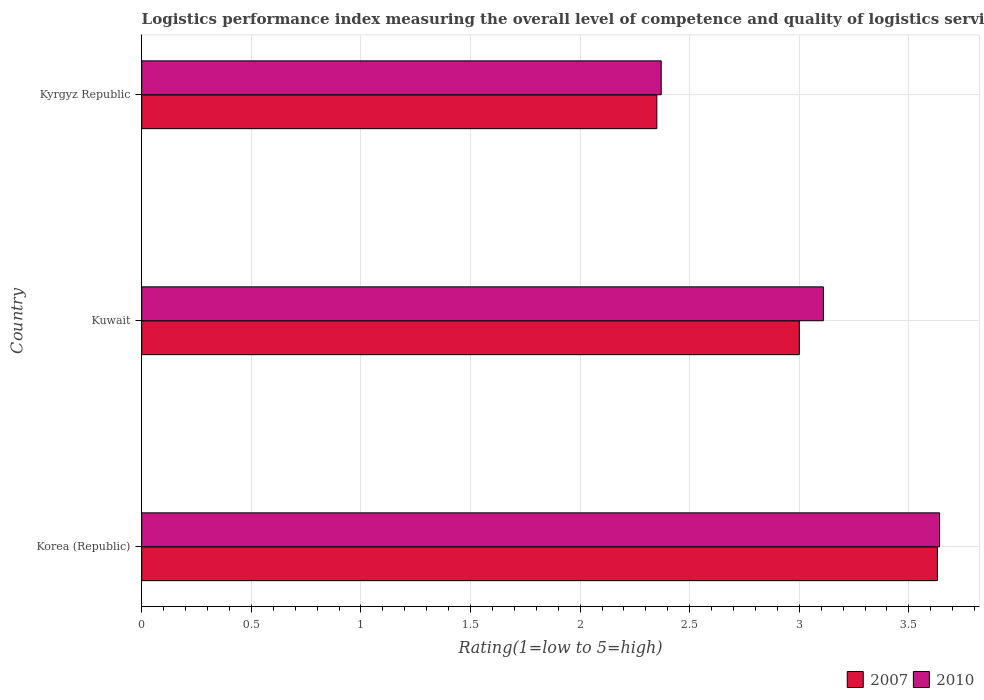How many bars are there on the 2nd tick from the bottom?
Offer a terse response. 2. What is the label of the 2nd group of bars from the top?
Provide a succinct answer. Kuwait. In how many cases, is the number of bars for a given country not equal to the number of legend labels?
Make the answer very short. 0. What is the Logistic performance index in 2010 in Kyrgyz Republic?
Your response must be concise. 2.37. Across all countries, what is the maximum Logistic performance index in 2007?
Keep it short and to the point. 3.63. Across all countries, what is the minimum Logistic performance index in 2007?
Offer a very short reply. 2.35. In which country was the Logistic performance index in 2007 minimum?
Offer a very short reply. Kyrgyz Republic. What is the total Logistic performance index in 2007 in the graph?
Your answer should be compact. 8.98. What is the difference between the Logistic performance index in 2007 in Korea (Republic) and that in Kyrgyz Republic?
Provide a succinct answer. 1.28. What is the difference between the Logistic performance index in 2007 in Kuwait and the Logistic performance index in 2010 in Korea (Republic)?
Ensure brevity in your answer.  -0.64. What is the average Logistic performance index in 2010 per country?
Provide a short and direct response. 3.04. What is the difference between the Logistic performance index in 2007 and Logistic performance index in 2010 in Korea (Republic)?
Make the answer very short. -0.01. What is the ratio of the Logistic performance index in 2010 in Korea (Republic) to that in Kyrgyz Republic?
Provide a succinct answer. 1.54. Is the Logistic performance index in 2007 in Kuwait less than that in Kyrgyz Republic?
Provide a succinct answer. No. Is the difference between the Logistic performance index in 2007 in Korea (Republic) and Kyrgyz Republic greater than the difference between the Logistic performance index in 2010 in Korea (Republic) and Kyrgyz Republic?
Ensure brevity in your answer.  Yes. What is the difference between the highest and the second highest Logistic performance index in 2010?
Your response must be concise. 0.53. What is the difference between the highest and the lowest Logistic performance index in 2007?
Your answer should be very brief. 1.28. How many bars are there?
Offer a very short reply. 6. Are the values on the major ticks of X-axis written in scientific E-notation?
Provide a short and direct response. No. Does the graph contain grids?
Provide a short and direct response. Yes. What is the title of the graph?
Your answer should be very brief. Logistics performance index measuring the overall level of competence and quality of logistics services. Does "2005" appear as one of the legend labels in the graph?
Offer a very short reply. No. What is the label or title of the X-axis?
Ensure brevity in your answer.  Rating(1=low to 5=high). What is the label or title of the Y-axis?
Offer a terse response. Country. What is the Rating(1=low to 5=high) in 2007 in Korea (Republic)?
Your answer should be compact. 3.63. What is the Rating(1=low to 5=high) of 2010 in Korea (Republic)?
Offer a terse response. 3.64. What is the Rating(1=low to 5=high) in 2007 in Kuwait?
Provide a short and direct response. 3. What is the Rating(1=low to 5=high) in 2010 in Kuwait?
Offer a very short reply. 3.11. What is the Rating(1=low to 5=high) of 2007 in Kyrgyz Republic?
Your answer should be very brief. 2.35. What is the Rating(1=low to 5=high) in 2010 in Kyrgyz Republic?
Provide a short and direct response. 2.37. Across all countries, what is the maximum Rating(1=low to 5=high) of 2007?
Your answer should be compact. 3.63. Across all countries, what is the maximum Rating(1=low to 5=high) of 2010?
Keep it short and to the point. 3.64. Across all countries, what is the minimum Rating(1=low to 5=high) in 2007?
Your answer should be compact. 2.35. Across all countries, what is the minimum Rating(1=low to 5=high) of 2010?
Give a very brief answer. 2.37. What is the total Rating(1=low to 5=high) in 2007 in the graph?
Make the answer very short. 8.98. What is the total Rating(1=low to 5=high) in 2010 in the graph?
Give a very brief answer. 9.12. What is the difference between the Rating(1=low to 5=high) of 2007 in Korea (Republic) and that in Kuwait?
Your answer should be very brief. 0.63. What is the difference between the Rating(1=low to 5=high) of 2010 in Korea (Republic) and that in Kuwait?
Keep it short and to the point. 0.53. What is the difference between the Rating(1=low to 5=high) in 2007 in Korea (Republic) and that in Kyrgyz Republic?
Keep it short and to the point. 1.28. What is the difference between the Rating(1=low to 5=high) in 2010 in Korea (Republic) and that in Kyrgyz Republic?
Offer a very short reply. 1.27. What is the difference between the Rating(1=low to 5=high) of 2007 in Kuwait and that in Kyrgyz Republic?
Provide a succinct answer. 0.65. What is the difference between the Rating(1=low to 5=high) in 2010 in Kuwait and that in Kyrgyz Republic?
Keep it short and to the point. 0.74. What is the difference between the Rating(1=low to 5=high) in 2007 in Korea (Republic) and the Rating(1=low to 5=high) in 2010 in Kuwait?
Provide a short and direct response. 0.52. What is the difference between the Rating(1=low to 5=high) of 2007 in Korea (Republic) and the Rating(1=low to 5=high) of 2010 in Kyrgyz Republic?
Provide a succinct answer. 1.26. What is the difference between the Rating(1=low to 5=high) of 2007 in Kuwait and the Rating(1=low to 5=high) of 2010 in Kyrgyz Republic?
Provide a succinct answer. 0.63. What is the average Rating(1=low to 5=high) of 2007 per country?
Offer a very short reply. 2.99. What is the average Rating(1=low to 5=high) of 2010 per country?
Your answer should be compact. 3.04. What is the difference between the Rating(1=low to 5=high) in 2007 and Rating(1=low to 5=high) in 2010 in Korea (Republic)?
Keep it short and to the point. -0.01. What is the difference between the Rating(1=low to 5=high) in 2007 and Rating(1=low to 5=high) in 2010 in Kuwait?
Provide a short and direct response. -0.11. What is the difference between the Rating(1=low to 5=high) of 2007 and Rating(1=low to 5=high) of 2010 in Kyrgyz Republic?
Offer a very short reply. -0.02. What is the ratio of the Rating(1=low to 5=high) of 2007 in Korea (Republic) to that in Kuwait?
Give a very brief answer. 1.21. What is the ratio of the Rating(1=low to 5=high) in 2010 in Korea (Republic) to that in Kuwait?
Offer a terse response. 1.17. What is the ratio of the Rating(1=low to 5=high) of 2007 in Korea (Republic) to that in Kyrgyz Republic?
Your response must be concise. 1.54. What is the ratio of the Rating(1=low to 5=high) in 2010 in Korea (Republic) to that in Kyrgyz Republic?
Offer a terse response. 1.54. What is the ratio of the Rating(1=low to 5=high) of 2007 in Kuwait to that in Kyrgyz Republic?
Keep it short and to the point. 1.28. What is the ratio of the Rating(1=low to 5=high) of 2010 in Kuwait to that in Kyrgyz Republic?
Give a very brief answer. 1.31. What is the difference between the highest and the second highest Rating(1=low to 5=high) of 2007?
Ensure brevity in your answer.  0.63. What is the difference between the highest and the second highest Rating(1=low to 5=high) of 2010?
Your answer should be compact. 0.53. What is the difference between the highest and the lowest Rating(1=low to 5=high) of 2007?
Make the answer very short. 1.28. What is the difference between the highest and the lowest Rating(1=low to 5=high) of 2010?
Your answer should be compact. 1.27. 